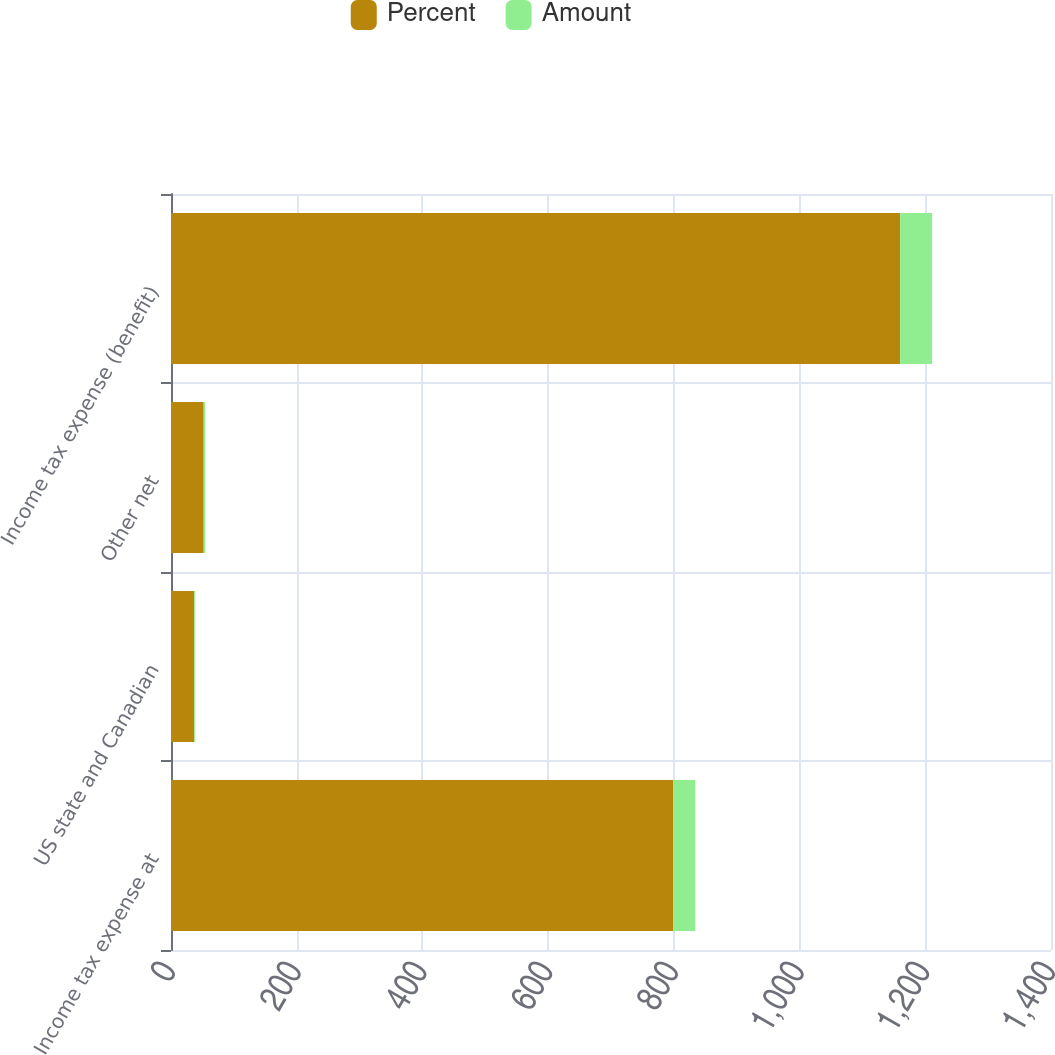Convert chart to OTSL. <chart><loc_0><loc_0><loc_500><loc_500><stacked_bar_chart><ecel><fcel>Income tax expense at<fcel>US state and Canadian<fcel>Other net<fcel>Income tax expense (benefit)<nl><fcel>Percent<fcel>799<fcel>37<fcel>52<fcel>1160<nl><fcel>Amount<fcel>35<fcel>1.6<fcel>2.3<fcel>50.9<nl></chart> 